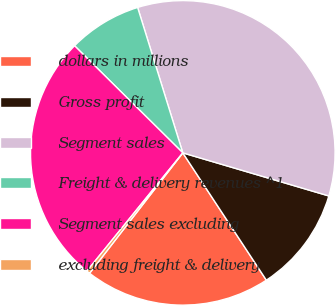Convert chart. <chart><loc_0><loc_0><loc_500><loc_500><pie_chart><fcel>dollars in millions<fcel>Gross profit<fcel>Segment sales<fcel>Freight & delivery revenues ^1<fcel>Segment sales excluding<fcel>excluding freight & delivery<nl><fcel>19.73%<fcel>11.19%<fcel>34.36%<fcel>7.79%<fcel>26.57%<fcel>0.36%<nl></chart> 